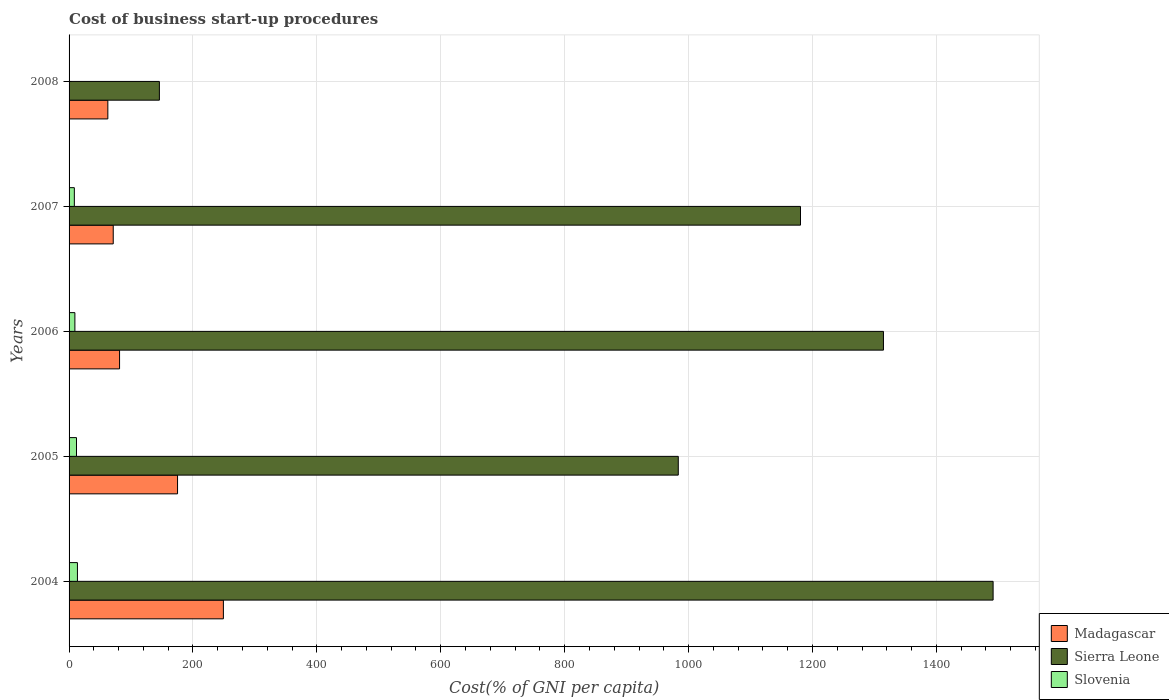How many groups of bars are there?
Your response must be concise. 5. In how many cases, is the number of bars for a given year not equal to the number of legend labels?
Your response must be concise. 0. Across all years, what is the maximum cost of business start-up procedures in Madagascar?
Keep it short and to the point. 249.1. Across all years, what is the minimum cost of business start-up procedures in Sierra Leone?
Offer a very short reply. 145.8. In which year was the cost of business start-up procedures in Madagascar minimum?
Provide a short and direct response. 2008. What is the total cost of business start-up procedures in Sierra Leone in the graph?
Your answer should be compact. 5116.1. What is the difference between the cost of business start-up procedures in Madagascar in 2005 and that in 2008?
Make the answer very short. 112.5. What is the difference between the cost of business start-up procedures in Madagascar in 2005 and the cost of business start-up procedures in Sierra Leone in 2007?
Ensure brevity in your answer.  -1005.6. What is the average cost of business start-up procedures in Sierra Leone per year?
Your answer should be compact. 1023.22. In the year 2004, what is the difference between the cost of business start-up procedures in Madagascar and cost of business start-up procedures in Sierra Leone?
Provide a short and direct response. -1242.5. In how many years, is the cost of business start-up procedures in Madagascar greater than 960 %?
Provide a short and direct response. 0. What is the ratio of the cost of business start-up procedures in Madagascar in 2004 to that in 2006?
Keep it short and to the point. 3.06. What is the difference between the highest and the second highest cost of business start-up procedures in Slovenia?
Your response must be concise. 1.5. What is the difference between the highest and the lowest cost of business start-up procedures in Sierra Leone?
Provide a succinct answer. 1345.8. In how many years, is the cost of business start-up procedures in Sierra Leone greater than the average cost of business start-up procedures in Sierra Leone taken over all years?
Ensure brevity in your answer.  3. Is the sum of the cost of business start-up procedures in Madagascar in 2004 and 2005 greater than the maximum cost of business start-up procedures in Slovenia across all years?
Your response must be concise. Yes. What does the 1st bar from the top in 2007 represents?
Keep it short and to the point. Slovenia. What does the 2nd bar from the bottom in 2004 represents?
Keep it short and to the point. Sierra Leone. How many bars are there?
Offer a terse response. 15. Are all the bars in the graph horizontal?
Your response must be concise. Yes. Does the graph contain grids?
Your answer should be compact. Yes. How many legend labels are there?
Your response must be concise. 3. What is the title of the graph?
Make the answer very short. Cost of business start-up procedures. Does "Morocco" appear as one of the legend labels in the graph?
Your answer should be compact. No. What is the label or title of the X-axis?
Offer a terse response. Cost(% of GNI per capita). What is the label or title of the Y-axis?
Make the answer very short. Years. What is the Cost(% of GNI per capita) of Madagascar in 2004?
Provide a succinct answer. 249.1. What is the Cost(% of GNI per capita) in Sierra Leone in 2004?
Offer a very short reply. 1491.6. What is the Cost(% of GNI per capita) of Madagascar in 2005?
Your answer should be very brief. 175.1. What is the Cost(% of GNI per capita) in Sierra Leone in 2005?
Your response must be concise. 983.4. What is the Cost(% of GNI per capita) in Madagascar in 2006?
Keep it short and to the point. 81.5. What is the Cost(% of GNI per capita) of Sierra Leone in 2006?
Offer a terse response. 1314.6. What is the Cost(% of GNI per capita) of Madagascar in 2007?
Ensure brevity in your answer.  71.3. What is the Cost(% of GNI per capita) in Sierra Leone in 2007?
Your answer should be compact. 1180.7. What is the Cost(% of GNI per capita) of Madagascar in 2008?
Offer a terse response. 62.6. What is the Cost(% of GNI per capita) in Sierra Leone in 2008?
Offer a terse response. 145.8. What is the Cost(% of GNI per capita) of Slovenia in 2008?
Keep it short and to the point. 0.1. Across all years, what is the maximum Cost(% of GNI per capita) in Madagascar?
Provide a short and direct response. 249.1. Across all years, what is the maximum Cost(% of GNI per capita) of Sierra Leone?
Your answer should be very brief. 1491.6. Across all years, what is the minimum Cost(% of GNI per capita) of Madagascar?
Make the answer very short. 62.6. Across all years, what is the minimum Cost(% of GNI per capita) in Sierra Leone?
Ensure brevity in your answer.  145.8. Across all years, what is the minimum Cost(% of GNI per capita) of Slovenia?
Provide a short and direct response. 0.1. What is the total Cost(% of GNI per capita) in Madagascar in the graph?
Offer a terse response. 639.6. What is the total Cost(% of GNI per capita) of Sierra Leone in the graph?
Offer a very short reply. 5116.1. What is the total Cost(% of GNI per capita) in Slovenia in the graph?
Provide a succinct answer. 43.5. What is the difference between the Cost(% of GNI per capita) of Sierra Leone in 2004 and that in 2005?
Provide a succinct answer. 508.2. What is the difference between the Cost(% of GNI per capita) of Madagascar in 2004 and that in 2006?
Ensure brevity in your answer.  167.6. What is the difference between the Cost(% of GNI per capita) in Sierra Leone in 2004 and that in 2006?
Your answer should be compact. 177. What is the difference between the Cost(% of GNI per capita) of Madagascar in 2004 and that in 2007?
Offer a terse response. 177.8. What is the difference between the Cost(% of GNI per capita) of Sierra Leone in 2004 and that in 2007?
Offer a very short reply. 310.9. What is the difference between the Cost(% of GNI per capita) in Madagascar in 2004 and that in 2008?
Give a very brief answer. 186.5. What is the difference between the Cost(% of GNI per capita) of Sierra Leone in 2004 and that in 2008?
Your answer should be very brief. 1345.8. What is the difference between the Cost(% of GNI per capita) in Madagascar in 2005 and that in 2006?
Your answer should be very brief. 93.6. What is the difference between the Cost(% of GNI per capita) of Sierra Leone in 2005 and that in 2006?
Provide a short and direct response. -331.2. What is the difference between the Cost(% of GNI per capita) in Madagascar in 2005 and that in 2007?
Make the answer very short. 103.8. What is the difference between the Cost(% of GNI per capita) in Sierra Leone in 2005 and that in 2007?
Your response must be concise. -197.3. What is the difference between the Cost(% of GNI per capita) in Slovenia in 2005 and that in 2007?
Your response must be concise. 3.5. What is the difference between the Cost(% of GNI per capita) in Madagascar in 2005 and that in 2008?
Provide a succinct answer. 112.5. What is the difference between the Cost(% of GNI per capita) of Sierra Leone in 2005 and that in 2008?
Offer a terse response. 837.6. What is the difference between the Cost(% of GNI per capita) of Madagascar in 2006 and that in 2007?
Your answer should be compact. 10.2. What is the difference between the Cost(% of GNI per capita) of Sierra Leone in 2006 and that in 2007?
Provide a short and direct response. 133.9. What is the difference between the Cost(% of GNI per capita) of Slovenia in 2006 and that in 2007?
Your answer should be compact. 0.9. What is the difference between the Cost(% of GNI per capita) in Sierra Leone in 2006 and that in 2008?
Offer a terse response. 1168.8. What is the difference between the Cost(% of GNI per capita) in Slovenia in 2006 and that in 2008?
Your response must be concise. 9.3. What is the difference between the Cost(% of GNI per capita) in Sierra Leone in 2007 and that in 2008?
Your response must be concise. 1034.9. What is the difference between the Cost(% of GNI per capita) in Madagascar in 2004 and the Cost(% of GNI per capita) in Sierra Leone in 2005?
Your response must be concise. -734.3. What is the difference between the Cost(% of GNI per capita) of Madagascar in 2004 and the Cost(% of GNI per capita) of Slovenia in 2005?
Provide a succinct answer. 237.1. What is the difference between the Cost(% of GNI per capita) of Sierra Leone in 2004 and the Cost(% of GNI per capita) of Slovenia in 2005?
Ensure brevity in your answer.  1479.6. What is the difference between the Cost(% of GNI per capita) in Madagascar in 2004 and the Cost(% of GNI per capita) in Sierra Leone in 2006?
Provide a short and direct response. -1065.5. What is the difference between the Cost(% of GNI per capita) in Madagascar in 2004 and the Cost(% of GNI per capita) in Slovenia in 2006?
Your answer should be compact. 239.7. What is the difference between the Cost(% of GNI per capita) in Sierra Leone in 2004 and the Cost(% of GNI per capita) in Slovenia in 2006?
Give a very brief answer. 1482.2. What is the difference between the Cost(% of GNI per capita) of Madagascar in 2004 and the Cost(% of GNI per capita) of Sierra Leone in 2007?
Offer a very short reply. -931.6. What is the difference between the Cost(% of GNI per capita) of Madagascar in 2004 and the Cost(% of GNI per capita) of Slovenia in 2007?
Provide a short and direct response. 240.6. What is the difference between the Cost(% of GNI per capita) in Sierra Leone in 2004 and the Cost(% of GNI per capita) in Slovenia in 2007?
Give a very brief answer. 1483.1. What is the difference between the Cost(% of GNI per capita) in Madagascar in 2004 and the Cost(% of GNI per capita) in Sierra Leone in 2008?
Your answer should be compact. 103.3. What is the difference between the Cost(% of GNI per capita) of Madagascar in 2004 and the Cost(% of GNI per capita) of Slovenia in 2008?
Give a very brief answer. 249. What is the difference between the Cost(% of GNI per capita) in Sierra Leone in 2004 and the Cost(% of GNI per capita) in Slovenia in 2008?
Provide a succinct answer. 1491.5. What is the difference between the Cost(% of GNI per capita) of Madagascar in 2005 and the Cost(% of GNI per capita) of Sierra Leone in 2006?
Your answer should be very brief. -1139.5. What is the difference between the Cost(% of GNI per capita) in Madagascar in 2005 and the Cost(% of GNI per capita) in Slovenia in 2006?
Ensure brevity in your answer.  165.7. What is the difference between the Cost(% of GNI per capita) of Sierra Leone in 2005 and the Cost(% of GNI per capita) of Slovenia in 2006?
Give a very brief answer. 974. What is the difference between the Cost(% of GNI per capita) of Madagascar in 2005 and the Cost(% of GNI per capita) of Sierra Leone in 2007?
Give a very brief answer. -1005.6. What is the difference between the Cost(% of GNI per capita) of Madagascar in 2005 and the Cost(% of GNI per capita) of Slovenia in 2007?
Offer a terse response. 166.6. What is the difference between the Cost(% of GNI per capita) of Sierra Leone in 2005 and the Cost(% of GNI per capita) of Slovenia in 2007?
Provide a short and direct response. 974.9. What is the difference between the Cost(% of GNI per capita) in Madagascar in 2005 and the Cost(% of GNI per capita) in Sierra Leone in 2008?
Keep it short and to the point. 29.3. What is the difference between the Cost(% of GNI per capita) in Madagascar in 2005 and the Cost(% of GNI per capita) in Slovenia in 2008?
Offer a very short reply. 175. What is the difference between the Cost(% of GNI per capita) of Sierra Leone in 2005 and the Cost(% of GNI per capita) of Slovenia in 2008?
Provide a succinct answer. 983.3. What is the difference between the Cost(% of GNI per capita) of Madagascar in 2006 and the Cost(% of GNI per capita) of Sierra Leone in 2007?
Give a very brief answer. -1099.2. What is the difference between the Cost(% of GNI per capita) of Madagascar in 2006 and the Cost(% of GNI per capita) of Slovenia in 2007?
Provide a succinct answer. 73. What is the difference between the Cost(% of GNI per capita) in Sierra Leone in 2006 and the Cost(% of GNI per capita) in Slovenia in 2007?
Give a very brief answer. 1306.1. What is the difference between the Cost(% of GNI per capita) in Madagascar in 2006 and the Cost(% of GNI per capita) in Sierra Leone in 2008?
Make the answer very short. -64.3. What is the difference between the Cost(% of GNI per capita) of Madagascar in 2006 and the Cost(% of GNI per capita) of Slovenia in 2008?
Provide a succinct answer. 81.4. What is the difference between the Cost(% of GNI per capita) of Sierra Leone in 2006 and the Cost(% of GNI per capita) of Slovenia in 2008?
Your answer should be very brief. 1314.5. What is the difference between the Cost(% of GNI per capita) of Madagascar in 2007 and the Cost(% of GNI per capita) of Sierra Leone in 2008?
Provide a short and direct response. -74.5. What is the difference between the Cost(% of GNI per capita) of Madagascar in 2007 and the Cost(% of GNI per capita) of Slovenia in 2008?
Offer a terse response. 71.2. What is the difference between the Cost(% of GNI per capita) in Sierra Leone in 2007 and the Cost(% of GNI per capita) in Slovenia in 2008?
Your answer should be compact. 1180.6. What is the average Cost(% of GNI per capita) of Madagascar per year?
Keep it short and to the point. 127.92. What is the average Cost(% of GNI per capita) of Sierra Leone per year?
Provide a short and direct response. 1023.22. What is the average Cost(% of GNI per capita) in Slovenia per year?
Offer a terse response. 8.7. In the year 2004, what is the difference between the Cost(% of GNI per capita) in Madagascar and Cost(% of GNI per capita) in Sierra Leone?
Make the answer very short. -1242.5. In the year 2004, what is the difference between the Cost(% of GNI per capita) in Madagascar and Cost(% of GNI per capita) in Slovenia?
Provide a short and direct response. 235.6. In the year 2004, what is the difference between the Cost(% of GNI per capita) of Sierra Leone and Cost(% of GNI per capita) of Slovenia?
Offer a terse response. 1478.1. In the year 2005, what is the difference between the Cost(% of GNI per capita) in Madagascar and Cost(% of GNI per capita) in Sierra Leone?
Make the answer very short. -808.3. In the year 2005, what is the difference between the Cost(% of GNI per capita) in Madagascar and Cost(% of GNI per capita) in Slovenia?
Give a very brief answer. 163.1. In the year 2005, what is the difference between the Cost(% of GNI per capita) of Sierra Leone and Cost(% of GNI per capita) of Slovenia?
Keep it short and to the point. 971.4. In the year 2006, what is the difference between the Cost(% of GNI per capita) in Madagascar and Cost(% of GNI per capita) in Sierra Leone?
Make the answer very short. -1233.1. In the year 2006, what is the difference between the Cost(% of GNI per capita) in Madagascar and Cost(% of GNI per capita) in Slovenia?
Give a very brief answer. 72.1. In the year 2006, what is the difference between the Cost(% of GNI per capita) in Sierra Leone and Cost(% of GNI per capita) in Slovenia?
Your answer should be very brief. 1305.2. In the year 2007, what is the difference between the Cost(% of GNI per capita) of Madagascar and Cost(% of GNI per capita) of Sierra Leone?
Make the answer very short. -1109.4. In the year 2007, what is the difference between the Cost(% of GNI per capita) in Madagascar and Cost(% of GNI per capita) in Slovenia?
Keep it short and to the point. 62.8. In the year 2007, what is the difference between the Cost(% of GNI per capita) of Sierra Leone and Cost(% of GNI per capita) of Slovenia?
Provide a short and direct response. 1172.2. In the year 2008, what is the difference between the Cost(% of GNI per capita) in Madagascar and Cost(% of GNI per capita) in Sierra Leone?
Ensure brevity in your answer.  -83.2. In the year 2008, what is the difference between the Cost(% of GNI per capita) in Madagascar and Cost(% of GNI per capita) in Slovenia?
Give a very brief answer. 62.5. In the year 2008, what is the difference between the Cost(% of GNI per capita) of Sierra Leone and Cost(% of GNI per capita) of Slovenia?
Offer a very short reply. 145.7. What is the ratio of the Cost(% of GNI per capita) in Madagascar in 2004 to that in 2005?
Provide a short and direct response. 1.42. What is the ratio of the Cost(% of GNI per capita) of Sierra Leone in 2004 to that in 2005?
Give a very brief answer. 1.52. What is the ratio of the Cost(% of GNI per capita) in Slovenia in 2004 to that in 2005?
Offer a very short reply. 1.12. What is the ratio of the Cost(% of GNI per capita) of Madagascar in 2004 to that in 2006?
Make the answer very short. 3.06. What is the ratio of the Cost(% of GNI per capita) in Sierra Leone in 2004 to that in 2006?
Offer a very short reply. 1.13. What is the ratio of the Cost(% of GNI per capita) of Slovenia in 2004 to that in 2006?
Offer a very short reply. 1.44. What is the ratio of the Cost(% of GNI per capita) of Madagascar in 2004 to that in 2007?
Provide a succinct answer. 3.49. What is the ratio of the Cost(% of GNI per capita) of Sierra Leone in 2004 to that in 2007?
Your answer should be very brief. 1.26. What is the ratio of the Cost(% of GNI per capita) of Slovenia in 2004 to that in 2007?
Provide a succinct answer. 1.59. What is the ratio of the Cost(% of GNI per capita) of Madagascar in 2004 to that in 2008?
Your answer should be compact. 3.98. What is the ratio of the Cost(% of GNI per capita) of Sierra Leone in 2004 to that in 2008?
Your answer should be compact. 10.23. What is the ratio of the Cost(% of GNI per capita) in Slovenia in 2004 to that in 2008?
Your answer should be very brief. 135. What is the ratio of the Cost(% of GNI per capita) in Madagascar in 2005 to that in 2006?
Provide a short and direct response. 2.15. What is the ratio of the Cost(% of GNI per capita) in Sierra Leone in 2005 to that in 2006?
Ensure brevity in your answer.  0.75. What is the ratio of the Cost(% of GNI per capita) in Slovenia in 2005 to that in 2006?
Offer a very short reply. 1.28. What is the ratio of the Cost(% of GNI per capita) of Madagascar in 2005 to that in 2007?
Your answer should be compact. 2.46. What is the ratio of the Cost(% of GNI per capita) in Sierra Leone in 2005 to that in 2007?
Ensure brevity in your answer.  0.83. What is the ratio of the Cost(% of GNI per capita) in Slovenia in 2005 to that in 2007?
Provide a short and direct response. 1.41. What is the ratio of the Cost(% of GNI per capita) of Madagascar in 2005 to that in 2008?
Give a very brief answer. 2.8. What is the ratio of the Cost(% of GNI per capita) of Sierra Leone in 2005 to that in 2008?
Give a very brief answer. 6.74. What is the ratio of the Cost(% of GNI per capita) in Slovenia in 2005 to that in 2008?
Make the answer very short. 120. What is the ratio of the Cost(% of GNI per capita) of Madagascar in 2006 to that in 2007?
Make the answer very short. 1.14. What is the ratio of the Cost(% of GNI per capita) in Sierra Leone in 2006 to that in 2007?
Make the answer very short. 1.11. What is the ratio of the Cost(% of GNI per capita) of Slovenia in 2006 to that in 2007?
Provide a short and direct response. 1.11. What is the ratio of the Cost(% of GNI per capita) in Madagascar in 2006 to that in 2008?
Offer a very short reply. 1.3. What is the ratio of the Cost(% of GNI per capita) of Sierra Leone in 2006 to that in 2008?
Offer a very short reply. 9.02. What is the ratio of the Cost(% of GNI per capita) of Slovenia in 2006 to that in 2008?
Make the answer very short. 94. What is the ratio of the Cost(% of GNI per capita) in Madagascar in 2007 to that in 2008?
Give a very brief answer. 1.14. What is the ratio of the Cost(% of GNI per capita) in Sierra Leone in 2007 to that in 2008?
Ensure brevity in your answer.  8.1. What is the difference between the highest and the second highest Cost(% of GNI per capita) in Madagascar?
Offer a very short reply. 74. What is the difference between the highest and the second highest Cost(% of GNI per capita) of Sierra Leone?
Your answer should be very brief. 177. What is the difference between the highest and the second highest Cost(% of GNI per capita) of Slovenia?
Your response must be concise. 1.5. What is the difference between the highest and the lowest Cost(% of GNI per capita) in Madagascar?
Ensure brevity in your answer.  186.5. What is the difference between the highest and the lowest Cost(% of GNI per capita) of Sierra Leone?
Your answer should be very brief. 1345.8. 